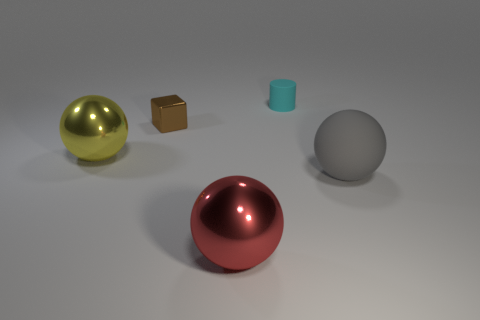Is there a big gray ball that is on the right side of the large metallic object on the left side of the red metal thing?
Offer a terse response. Yes. Are the large red sphere and the gray ball made of the same material?
Keep it short and to the point. No. The large object that is both on the right side of the tiny brown metallic block and left of the large rubber sphere has what shape?
Provide a short and direct response. Sphere. How big is the sphere on the right side of the sphere that is in front of the gray thing?
Offer a very short reply. Large. How many tiny cyan rubber things are the same shape as the tiny brown object?
Offer a terse response. 0. Is the small matte thing the same color as the tiny metallic block?
Keep it short and to the point. No. Is there anything else that has the same shape as the red metallic object?
Provide a short and direct response. Yes. Is there a block of the same color as the small matte thing?
Provide a short and direct response. No. Do the big thing to the right of the small cyan matte object and the tiny object that is to the right of the tiny shiny cube have the same material?
Provide a short and direct response. Yes. What is the color of the small rubber thing?
Provide a succinct answer. Cyan. 